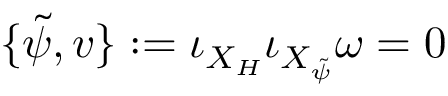Convert formula to latex. <formula><loc_0><loc_0><loc_500><loc_500>\{ \tilde { \psi } , v \} \colon = \iota _ { X _ { H } } \iota _ { X _ { \tilde { \psi } } } \omega = 0</formula> 